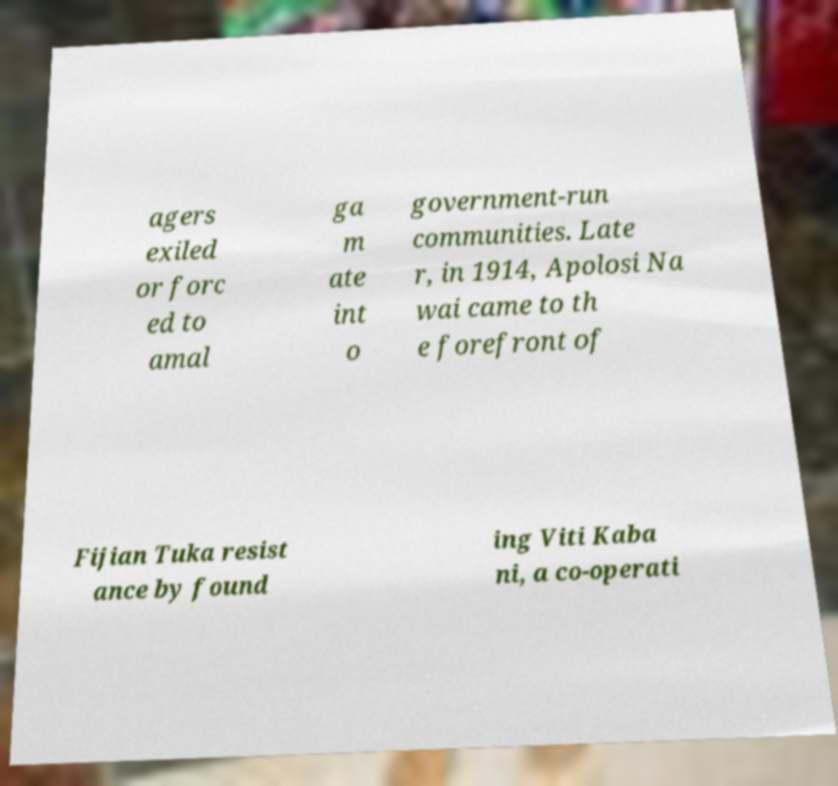There's text embedded in this image that I need extracted. Can you transcribe it verbatim? agers exiled or forc ed to amal ga m ate int o government-run communities. Late r, in 1914, Apolosi Na wai came to th e forefront of Fijian Tuka resist ance by found ing Viti Kaba ni, a co-operati 